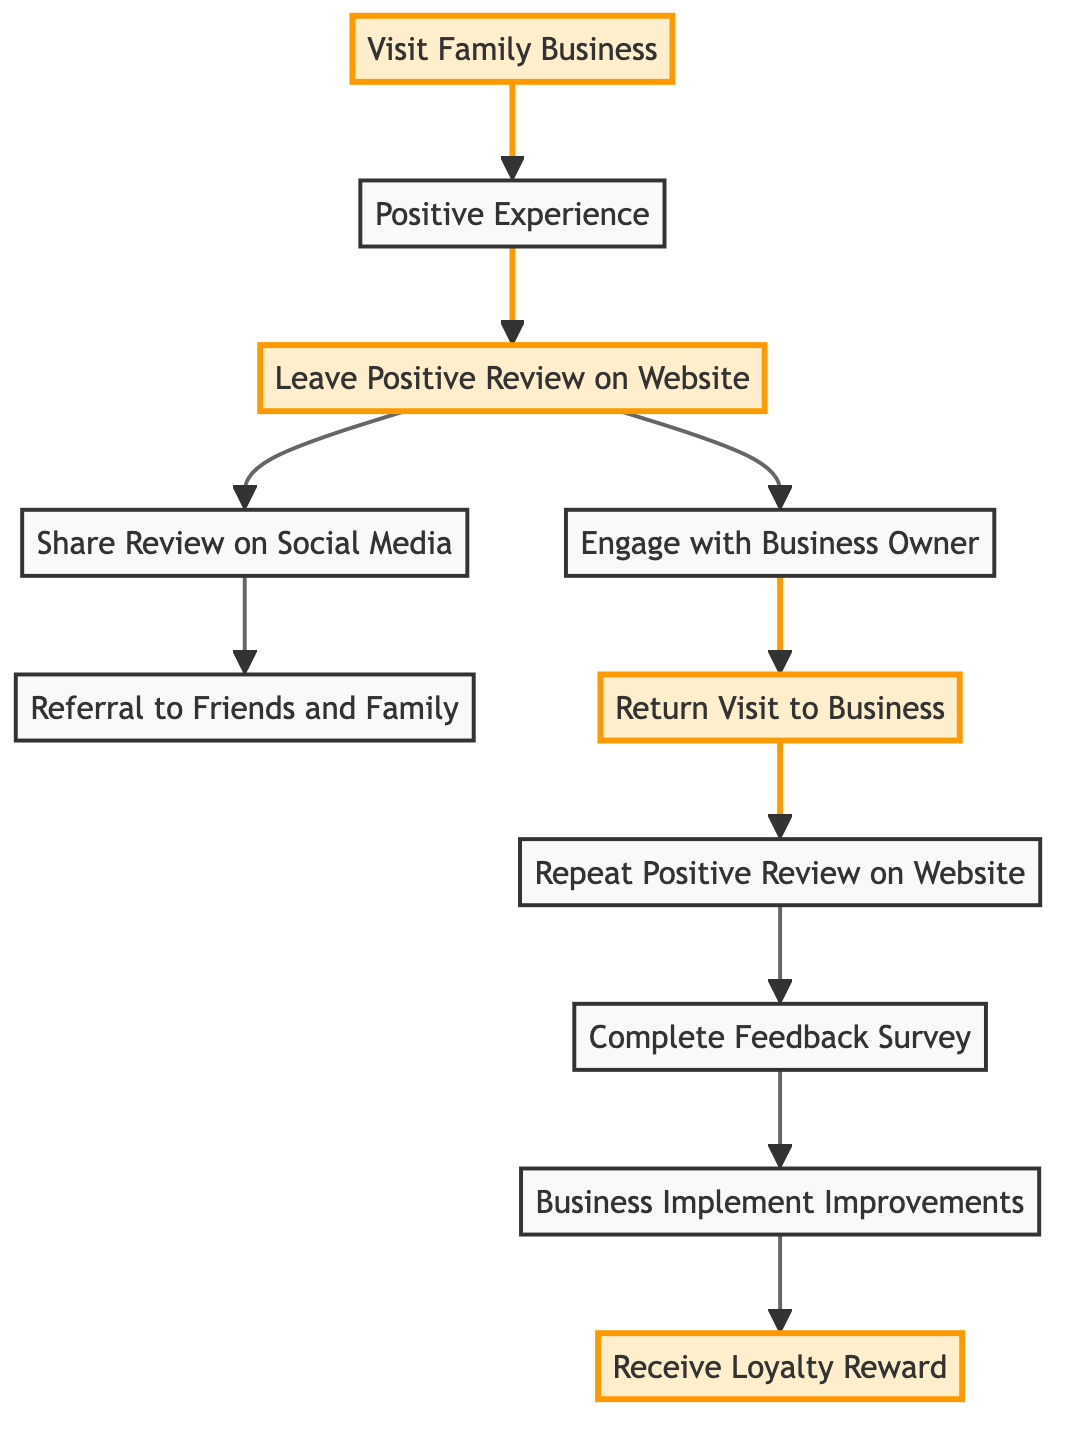What is the first step in the customer feedback journey? According to the diagram, the first step is represented by the node labeled "Visit Family Business." This node is the starting point of the journey and initiates the process leading to customer feedback.
Answer: Visit Family Business How many nodes are there in the diagram? By counting the nodes listed in the data, we see there are a total of 11 distinct nodes representing different stages of the customer feedback journey.
Answer: 11 What node comes after "Leave Positive Review on Website"? In the directed graph, the node that follows "Leave Positive Review on Website" is "Share Review on Social Media," as there is a direct edge leading from the first to the second node.
Answer: Share Review on Social Media What are the two nodes that follow "Positive Experience"? The two nodes that directly follow "Positive Experience" are "Leave Positive Review on Website" and there is another path that leads to sharing and engagement later on, but the immediate next is only "Leave Positive Review on Website."
Answer: Leave Positive Review on Website Which node receives feedback to improve business practices? The node responsible for receiving feedback and leading to improvements is "Business Implement Improvements," which is reached after the "Complete Feedback Survey" node. This means that customer feedback leads to potential changes in the family business.
Answer: Business Implement Improvements What are the final steps a customer receives after engaging with the business? The final steps after a customer engages with the business include "Return Visit to Business," which then leads to "Repeat Positive Review," followed by completing a survey, business improvement, and receiving loyalty rewards. This sequence is connected through specific edges in the graph indicating flow.
Answer: Receive Loyalty Reward Which nodes indicate customer referral to others? The node that indicates customer referral is "Referral to Friends and Family," which is reached after the customer shares their review on social media, highlighting the influence of social media in spreading awareness about the business.
Answer: Referral to Friends and Family What step occurs after receiving a loyalty reward? According to the diagram, there are no further steps after receiving a loyalty reward, as it is the last node in the directed graph. This suggests that the journey can cycle back to the beginning with a new visit after receiving the reward.
Answer: None 